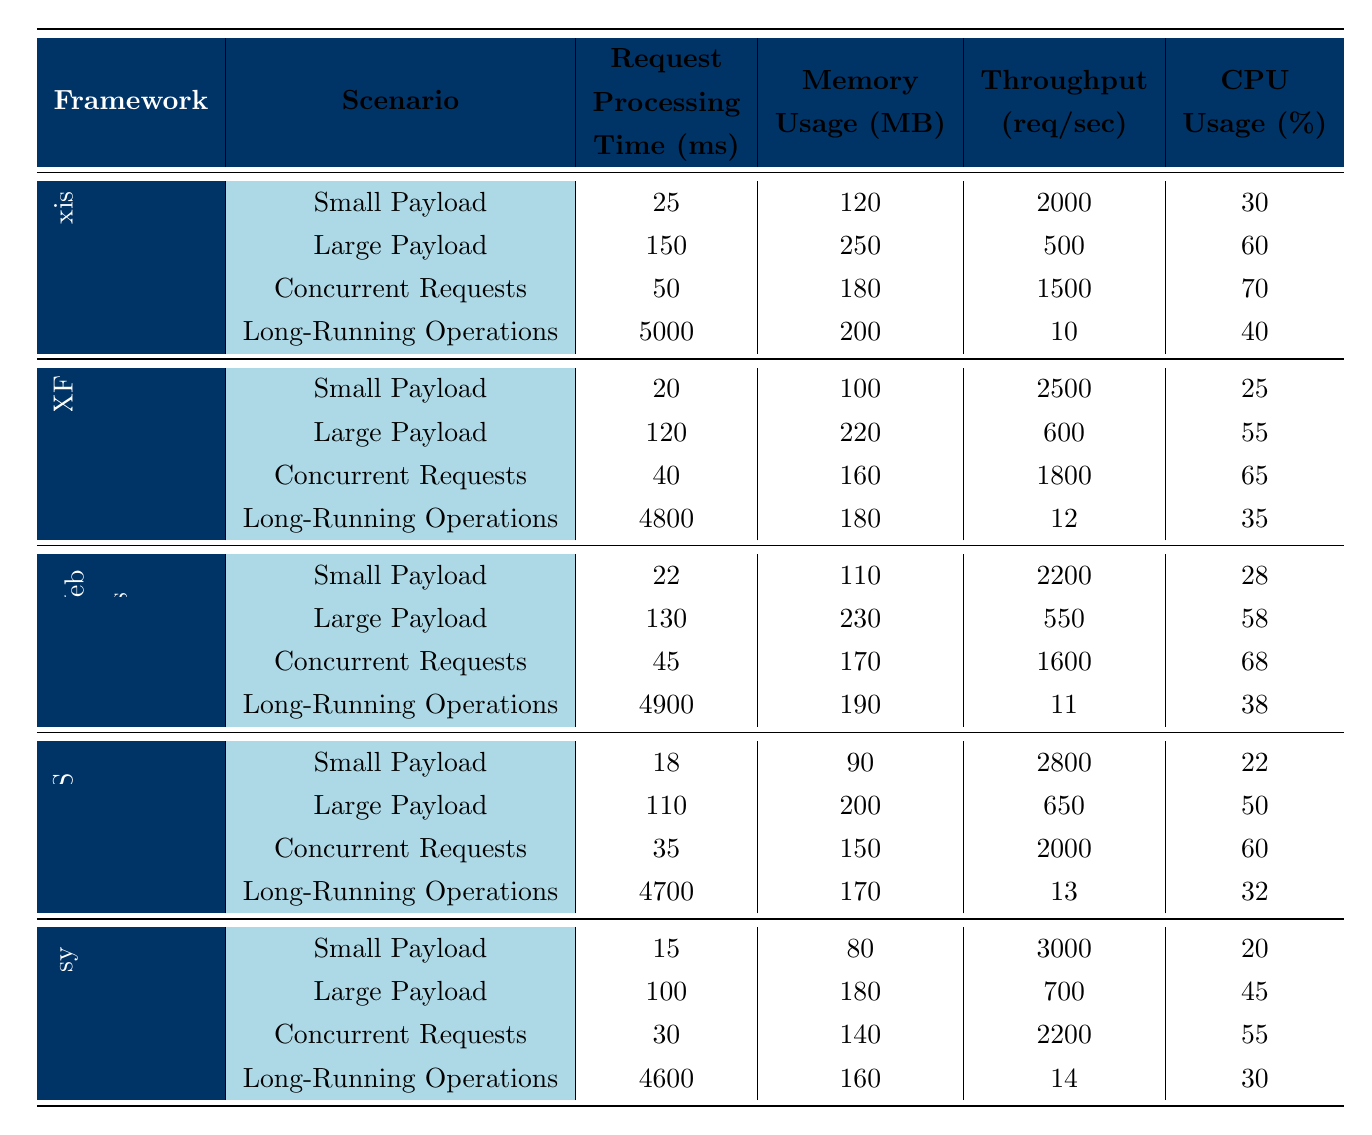What is the request processing time for Apache Axis in the "Small Payload" scenario? The "Small Payload" scenario for Apache Axis shows a request processing time of 25 ms in the table.
Answer: 25 ms Which framework has the highest throughput in the "Large Payload" scenario? In the "Large Payload" scenario, JAX-WS has the highest throughput with 650 requests/sec, while the other frameworks have lower values.
Answer: JAX-WS What is the average CPU usage for the "Concurrent Requests" scenario across all frameworks? The CPU usage for the "Concurrent Requests" scenario is: Apache Axis (70) + Apache CXF (65) + Spring Web Services (68) + JAX-WS (60) + RESTEasy (55) = 388. There are 5 frameworks, so the average is 388/5 = 77.6%.
Answer: 77.6% Does RESTEasy have a higher memory usage than Apache Axis for "Long-Running Operations"? For "Long-Running Operations," RESTEasy uses 160 MB while Apache Axis uses 200 MB, indicating that RESTEasy has lower memory usage.
Answer: No What is the latency difference between Apache CXF and JAX-WS in the "Small Payload" scenario? The latency for Apache CXF in the "Small Payload" scenario is 12 ms and for JAX-WS it is 10 ms. The difference is 12 - 10 = 2 ms.
Answer: 2 ms Which framework has the lowest memory usage in the "Small Payload" scenario? In the "Small Payload" scenario, RESTEasy has the lowest memory usage at 80 MB compared to the others.
Answer: RESTEasy What is the total request processing time for all frameworks in the "Long-Running Operations" scenario? The total request processing time is calculated by adding each framework's time: Apache Axis (5000) + Apache CXF (4800) + Spring Web Services (4900) + JAX-WS (4700) + RESTEasy (4600) = 24000 ms.
Answer: 24000 ms Is the throughput for Apache Axis in the "Concurrent Requests" scenario greater than 1600 requests/sec? The throughput for Apache Axis in the "Concurrent Requests" scenario is 1500 requests/sec, which is less than 1600.
Answer: No What is the percentage difference in CPU usage between Apache CXF and RESTEasy for the "Small Payload" scenario? The CPU usage for Apache CXF is 25%, and for RESTEasy, it is 20%. The difference is 25 - 20 = 5%, giving a percentage difference of (5/20)*100 = 25%.
Answer: 25% Which framework shows the best performance in terms of request processing time for the "Large Payload" scenario? The table shows that Apache CXF has the best request processing time of 120 ms for "Large Payload," which is the lowest among all frameworks tested.
Answer: Apache CXF 